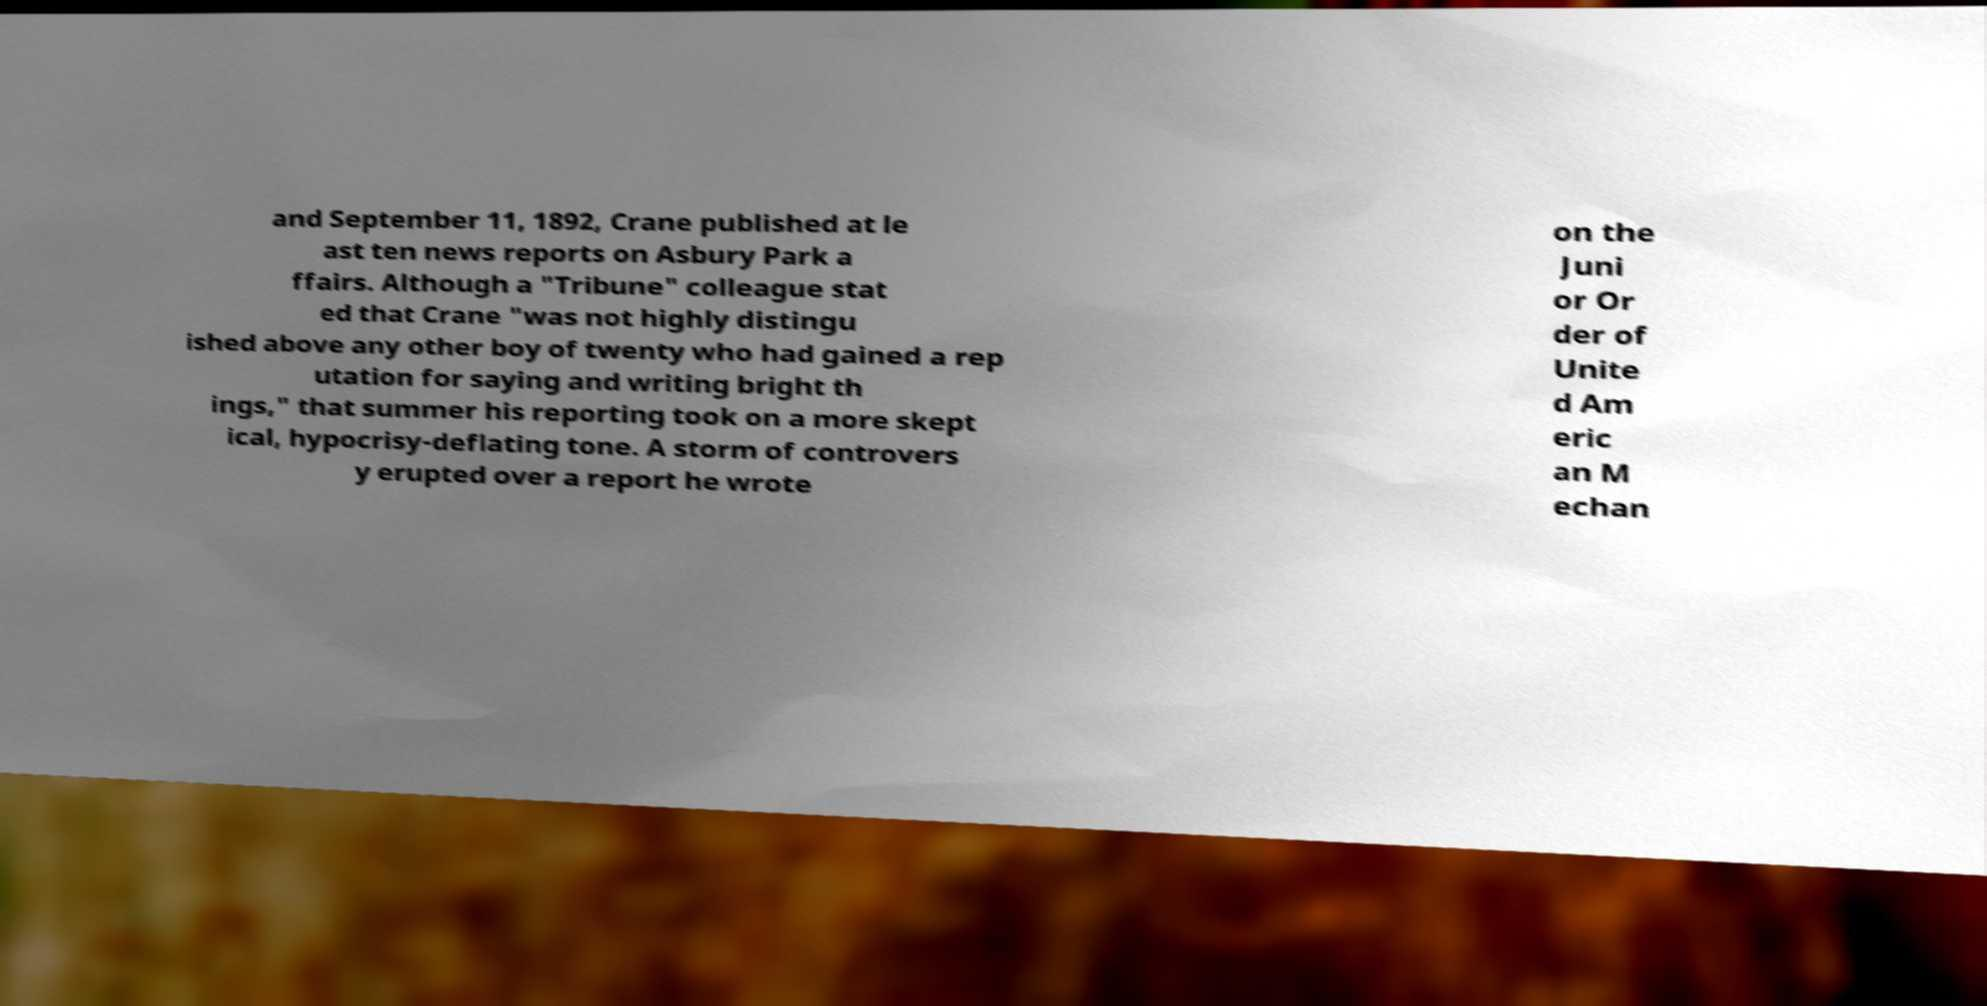There's text embedded in this image that I need extracted. Can you transcribe it verbatim? and September 11, 1892, Crane published at le ast ten news reports on Asbury Park a ffairs. Although a "Tribune" colleague stat ed that Crane "was not highly distingu ished above any other boy of twenty who had gained a rep utation for saying and writing bright th ings," that summer his reporting took on a more skept ical, hypocrisy-deflating tone. A storm of controvers y erupted over a report he wrote on the Juni or Or der of Unite d Am eric an M echan 